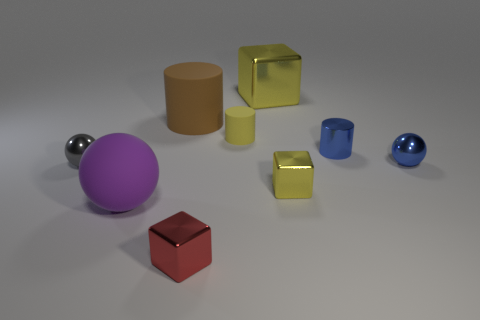There is a yellow metal thing behind the small gray metallic thing; does it have the same shape as the tiny metal object that is to the left of the large purple ball?
Give a very brief answer. No. Is there anything else that has the same material as the small red object?
Ensure brevity in your answer.  Yes. What is the big yellow block made of?
Offer a very short reply. Metal. There is a tiny yellow thing to the right of the tiny yellow matte cylinder; what is it made of?
Offer a very short reply. Metal. Are there any other things that have the same color as the big rubber cylinder?
Your answer should be compact. No. There is a purple thing that is made of the same material as the big cylinder; what is its size?
Provide a succinct answer. Large. How many big objects are either brown rubber cylinders or blue metallic things?
Offer a very short reply. 1. What is the size of the yellow object that is on the left side of the metallic block behind the small metal sphere that is on the right side of the brown matte cylinder?
Provide a short and direct response. Small. How many other metallic balls have the same size as the gray sphere?
Give a very brief answer. 1. What number of things are large balls or yellow shiny things that are in front of the brown matte cylinder?
Your answer should be compact. 2. 